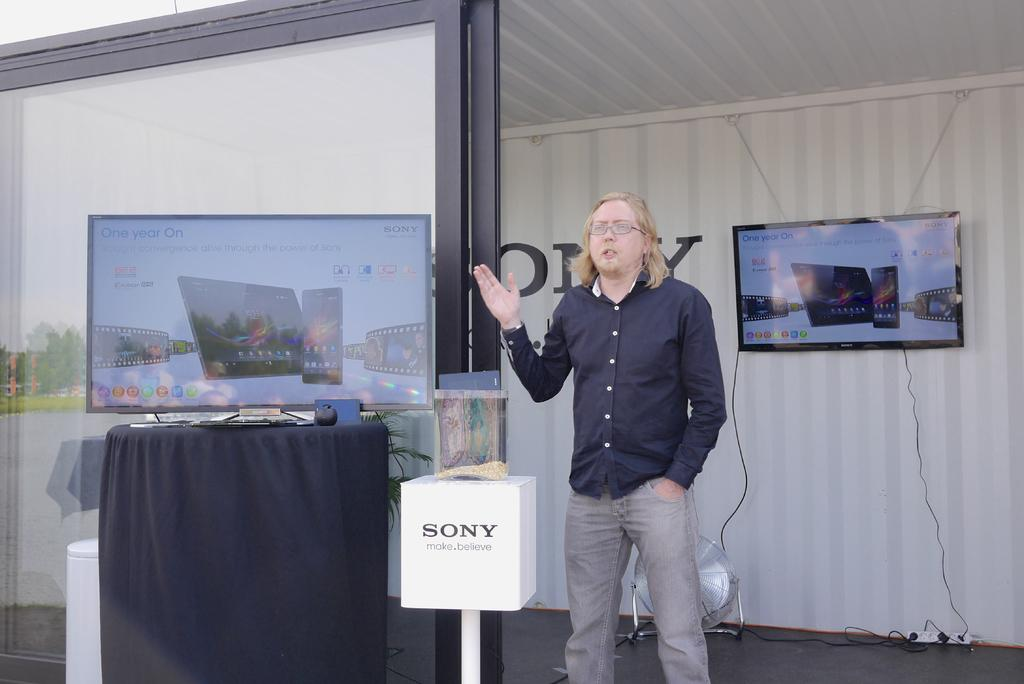<image>
Write a terse but informative summary of the picture. a man making a presentation next to a box that says sony 